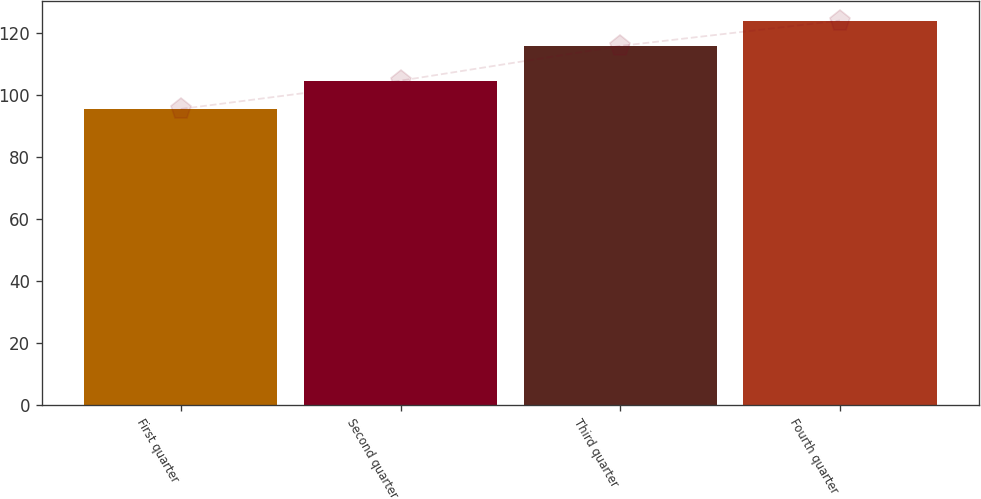<chart> <loc_0><loc_0><loc_500><loc_500><bar_chart><fcel>First quarter<fcel>Second quarter<fcel>Third quarter<fcel>Fourth quarter<nl><fcel>95.59<fcel>104.74<fcel>115.97<fcel>124.17<nl></chart> 